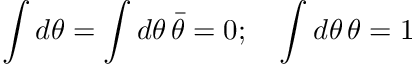Convert formula to latex. <formula><loc_0><loc_0><loc_500><loc_500>\int d \theta = \int d \theta \, \bar { \theta } = 0 ; \quad \int d \theta \, \theta = 1</formula> 